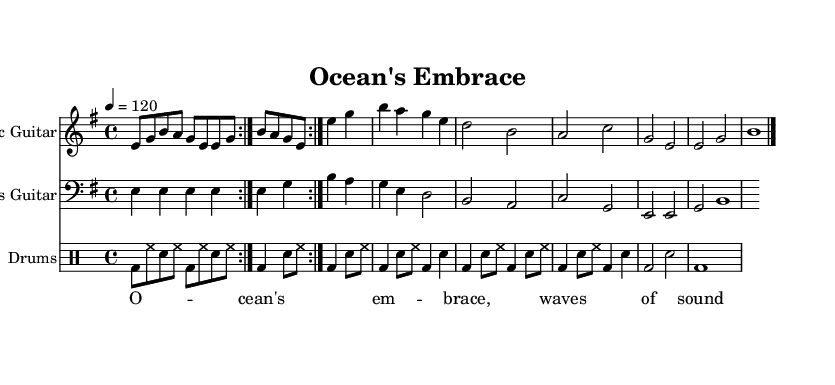What is the key signature of this music? The key signature indicates that there is one sharp (F#), which means the key is E minor.
Answer: E minor What is the time signature of this music? The time signature is found at the beginning and shows a 4 over 4, indicating that there are four beats in each measure.
Answer: 4/4 What is the tempo marking for this piece? The tempo marking specifies a speed of 120 beats per minute, shown at the beginning as "4 = 120."
Answer: 120 How many measures are there in the guitar riff repeated? By observing the guitar section, we see the riff is indicated to repeat for 4 times before the next section starts, making it 4 measures long.
Answer: 4 Which instrument plays the main melody? The electric guitar is the primary instrument for the melody, as indicated in the first staff of the score.
Answer: Electric Guitar What is the lyric line for the chorus? The lyrics presented above the staff spell out "Ocean's embrace, waves of sound," which corresponds to the section where the chorus occurs.
Answer: Ocean's embrace, waves of sound What rhythmic pattern does the drums part primarily use? The drum pattern includes a repeating combination of bass drum, hi-hat, and snare, indicated by the various rhythmic notations throughout the drum staff.
Answer: Bass drum, hi-hat, snare 